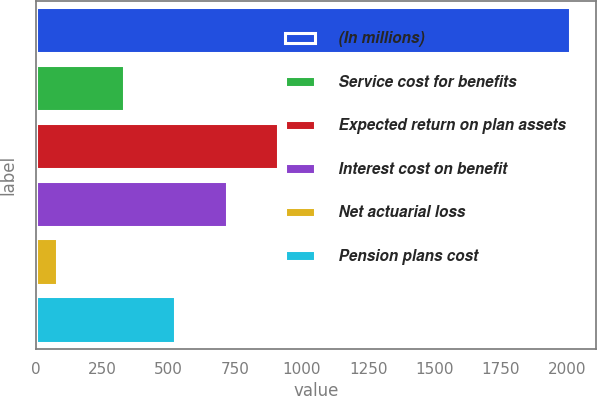Convert chart. <chart><loc_0><loc_0><loc_500><loc_500><bar_chart><fcel>(In millions)<fcel>Service cost for benefits<fcel>Expected return on plan assets<fcel>Interest cost on benefit<fcel>Net actuarial loss<fcel>Pension plans cost<nl><fcel>2008<fcel>332<fcel>910.7<fcel>717.8<fcel>79<fcel>524.9<nl></chart> 